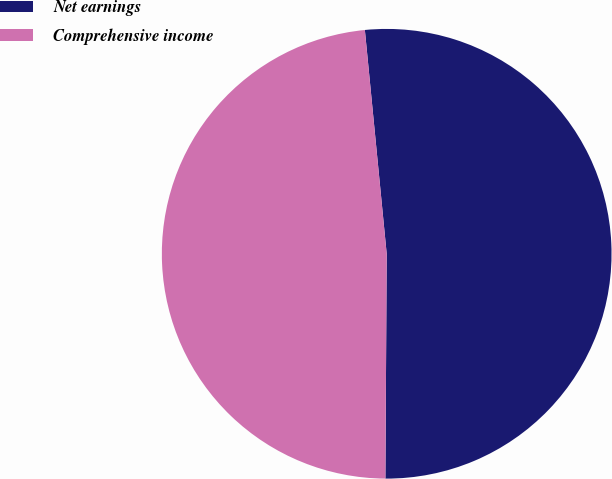Convert chart. <chart><loc_0><loc_0><loc_500><loc_500><pie_chart><fcel>Net earnings<fcel>Comprehensive income<nl><fcel>51.64%<fcel>48.36%<nl></chart> 